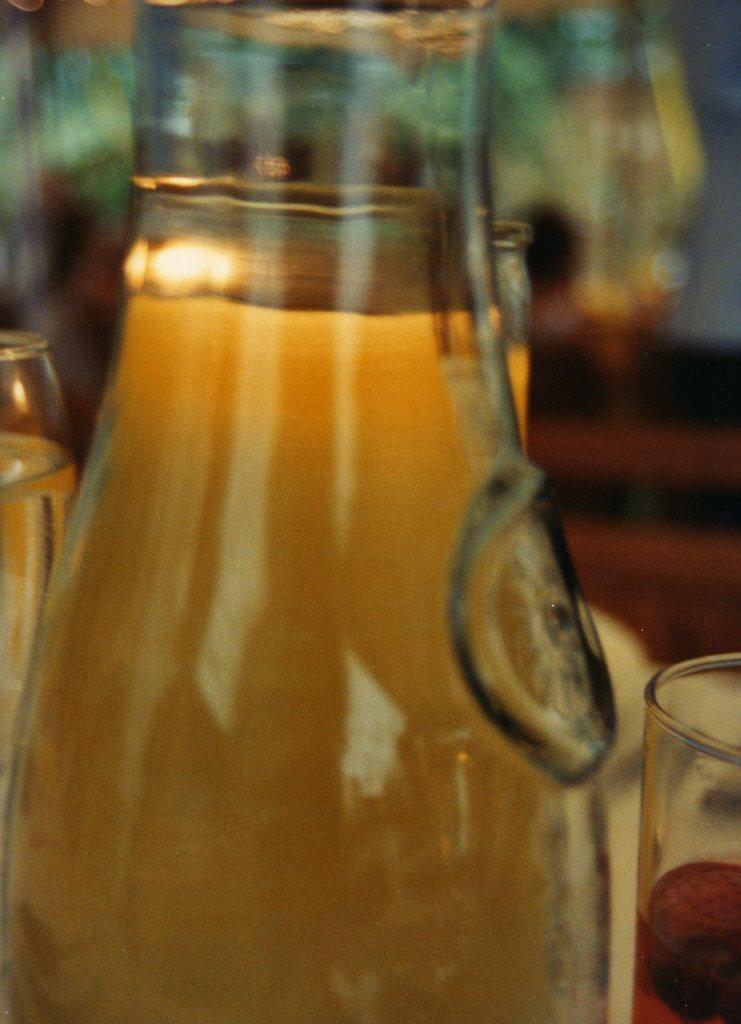Can you describe this image briefly? This picture shows a bottle with some drink filled in it. Beside the bottle there is a glass placed on the table. 